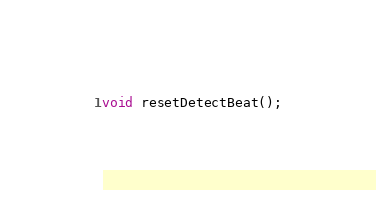<code> <loc_0><loc_0><loc_500><loc_500><_C_>void resetDetectBeat();
</code> 